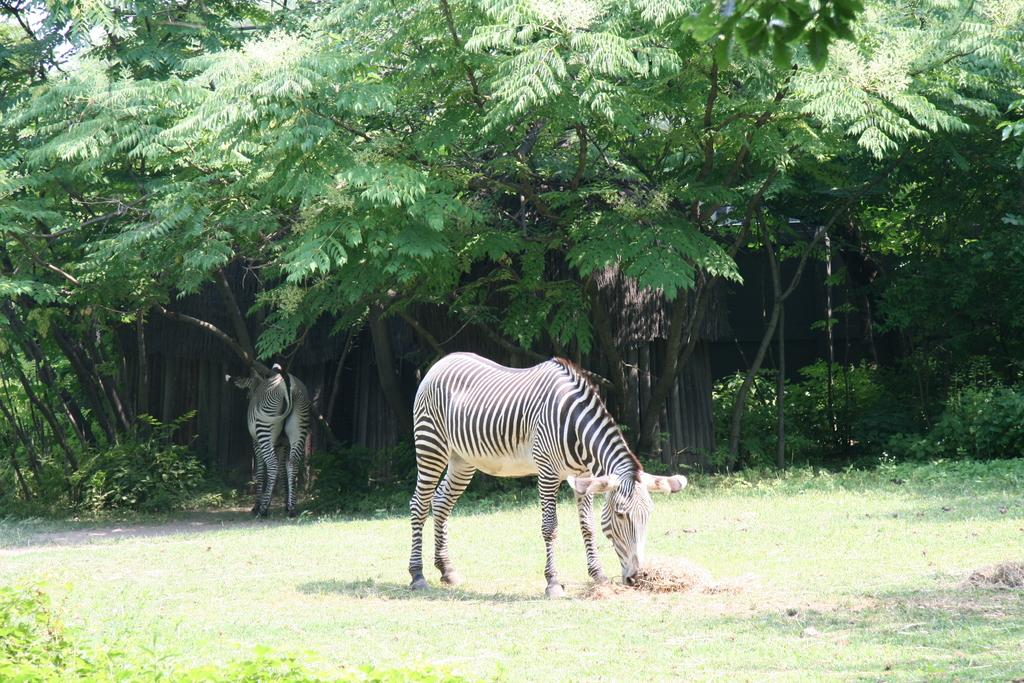How many animals are present in the image? There are two animals in the image. What is the position of the animals in the image? The animals are standing on the ground. What is the color scheme of the animals in the image? The animals are in black and white color. What can be seen in the background of the image? There are many trees and the sky visible in the background of the image. What type of toys are the animals playing with in the image? There are no toys present in the image; the animals are standing on the ground. Is there any popcorn visible in the image? There is no popcorn present in the image. 